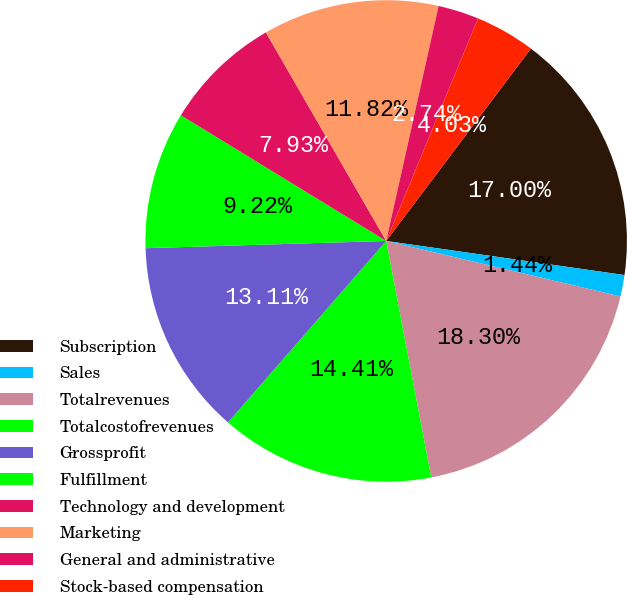<chart> <loc_0><loc_0><loc_500><loc_500><pie_chart><fcel>Subscription<fcel>Sales<fcel>Totalrevenues<fcel>Totalcostofrevenues<fcel>Grossprofit<fcel>Fulfillment<fcel>Technology and development<fcel>Marketing<fcel>General and administrative<fcel>Stock-based compensation<nl><fcel>17.0%<fcel>1.44%<fcel>18.3%<fcel>14.41%<fcel>13.11%<fcel>9.22%<fcel>7.93%<fcel>11.82%<fcel>2.74%<fcel>4.03%<nl></chart> 